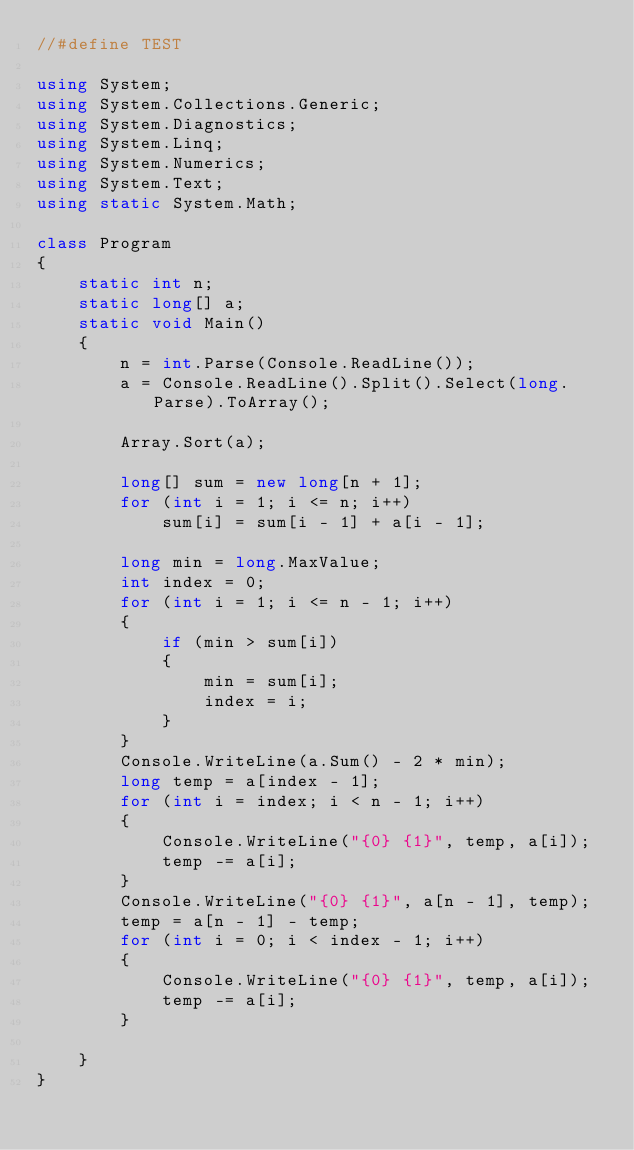Convert code to text. <code><loc_0><loc_0><loc_500><loc_500><_C#_>//#define TEST

using System;
using System.Collections.Generic;
using System.Diagnostics;
using System.Linq;
using System.Numerics;
using System.Text;
using static System.Math;

class Program
{
    static int n;
    static long[] a;
    static void Main()
    {
        n = int.Parse(Console.ReadLine());
        a = Console.ReadLine().Split().Select(long.Parse).ToArray();

        Array.Sort(a);

        long[] sum = new long[n + 1];
        for (int i = 1; i <= n; i++)
            sum[i] = sum[i - 1] + a[i - 1];

        long min = long.MaxValue;
        int index = 0;
        for (int i = 1; i <= n - 1; i++)
        {
            if (min > sum[i])
            {
                min = sum[i];
                index = i;
            }
        }
        Console.WriteLine(a.Sum() - 2 * min);
        long temp = a[index - 1];
        for (int i = index; i < n - 1; i++)
        {
            Console.WriteLine("{0} {1}", temp, a[i]);
            temp -= a[i];
        }
        Console.WriteLine("{0} {1}", a[n - 1], temp);
        temp = a[n - 1] - temp;
        for (int i = 0; i < index - 1; i++)
        {
            Console.WriteLine("{0} {1}", temp, a[i]);
            temp -= a[i];
        }

    }
}</code> 